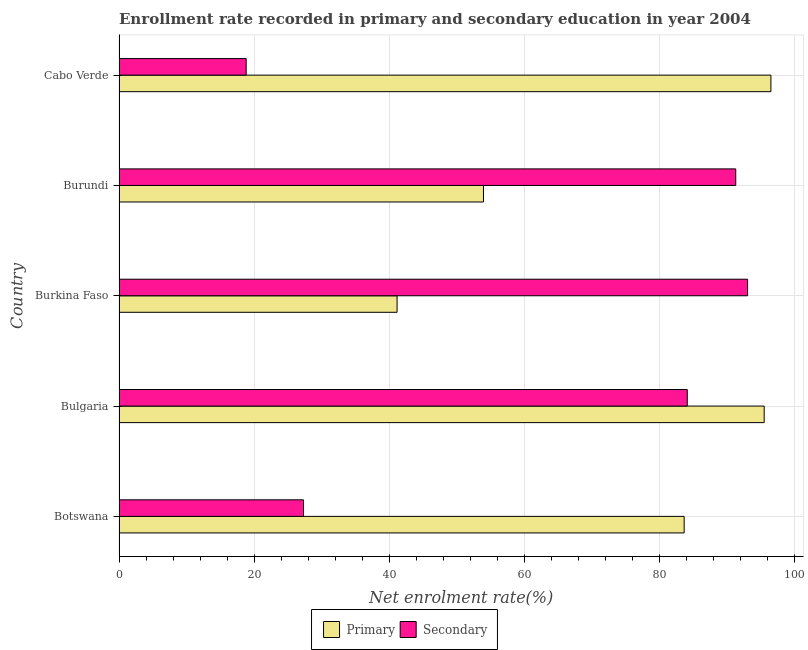How many different coloured bars are there?
Your answer should be compact. 2. Are the number of bars on each tick of the Y-axis equal?
Ensure brevity in your answer.  Yes. What is the label of the 4th group of bars from the top?
Your response must be concise. Bulgaria. What is the enrollment rate in primary education in Burundi?
Give a very brief answer. 53.93. Across all countries, what is the maximum enrollment rate in primary education?
Offer a very short reply. 96.46. Across all countries, what is the minimum enrollment rate in primary education?
Provide a short and direct response. 41.14. In which country was the enrollment rate in secondary education maximum?
Provide a short and direct response. Burkina Faso. In which country was the enrollment rate in primary education minimum?
Make the answer very short. Burkina Faso. What is the total enrollment rate in primary education in the graph?
Give a very brief answer. 370.61. What is the difference between the enrollment rate in primary education in Bulgaria and that in Cabo Verde?
Give a very brief answer. -0.99. What is the difference between the enrollment rate in secondary education in Burundi and the enrollment rate in primary education in Cabo Verde?
Ensure brevity in your answer.  -5.2. What is the average enrollment rate in primary education per country?
Ensure brevity in your answer.  74.12. What is the difference between the enrollment rate in primary education and enrollment rate in secondary education in Burundi?
Your answer should be compact. -37.33. What is the ratio of the enrollment rate in secondary education in Bulgaria to that in Cabo Verde?
Provide a short and direct response. 4.47. What is the difference between the highest and the second highest enrollment rate in secondary education?
Keep it short and to the point. 1.75. What is the difference between the highest and the lowest enrollment rate in primary education?
Make the answer very short. 55.32. In how many countries, is the enrollment rate in secondary education greater than the average enrollment rate in secondary education taken over all countries?
Your answer should be very brief. 3. Is the sum of the enrollment rate in secondary education in Botswana and Burundi greater than the maximum enrollment rate in primary education across all countries?
Your response must be concise. Yes. What does the 2nd bar from the top in Burkina Faso represents?
Provide a short and direct response. Primary. What does the 1st bar from the bottom in Cabo Verde represents?
Ensure brevity in your answer.  Primary. Are all the bars in the graph horizontal?
Give a very brief answer. Yes. How many countries are there in the graph?
Ensure brevity in your answer.  5. What is the difference between two consecutive major ticks on the X-axis?
Provide a short and direct response. 20. Are the values on the major ticks of X-axis written in scientific E-notation?
Ensure brevity in your answer.  No. Does the graph contain grids?
Offer a terse response. Yes. How are the legend labels stacked?
Make the answer very short. Horizontal. What is the title of the graph?
Provide a succinct answer. Enrollment rate recorded in primary and secondary education in year 2004. Does "% of GNI" appear as one of the legend labels in the graph?
Keep it short and to the point. No. What is the label or title of the X-axis?
Your response must be concise. Net enrolment rate(%). What is the label or title of the Y-axis?
Provide a short and direct response. Country. What is the Net enrolment rate(%) of Primary in Botswana?
Keep it short and to the point. 83.62. What is the Net enrolment rate(%) of Secondary in Botswana?
Offer a very short reply. 27.29. What is the Net enrolment rate(%) of Primary in Bulgaria?
Provide a succinct answer. 95.46. What is the Net enrolment rate(%) of Secondary in Bulgaria?
Give a very brief answer. 84.08. What is the Net enrolment rate(%) in Primary in Burkina Faso?
Provide a short and direct response. 41.14. What is the Net enrolment rate(%) of Secondary in Burkina Faso?
Your answer should be compact. 93.01. What is the Net enrolment rate(%) in Primary in Burundi?
Give a very brief answer. 53.93. What is the Net enrolment rate(%) in Secondary in Burundi?
Offer a terse response. 91.26. What is the Net enrolment rate(%) of Primary in Cabo Verde?
Keep it short and to the point. 96.46. What is the Net enrolment rate(%) of Secondary in Cabo Verde?
Your answer should be compact. 18.81. Across all countries, what is the maximum Net enrolment rate(%) in Primary?
Ensure brevity in your answer.  96.46. Across all countries, what is the maximum Net enrolment rate(%) of Secondary?
Provide a short and direct response. 93.01. Across all countries, what is the minimum Net enrolment rate(%) in Primary?
Provide a short and direct response. 41.14. Across all countries, what is the minimum Net enrolment rate(%) of Secondary?
Your response must be concise. 18.81. What is the total Net enrolment rate(%) in Primary in the graph?
Offer a terse response. 370.61. What is the total Net enrolment rate(%) of Secondary in the graph?
Keep it short and to the point. 314.45. What is the difference between the Net enrolment rate(%) of Primary in Botswana and that in Bulgaria?
Give a very brief answer. -11.84. What is the difference between the Net enrolment rate(%) in Secondary in Botswana and that in Bulgaria?
Make the answer very short. -56.79. What is the difference between the Net enrolment rate(%) of Primary in Botswana and that in Burkina Faso?
Your answer should be compact. 42.48. What is the difference between the Net enrolment rate(%) of Secondary in Botswana and that in Burkina Faso?
Offer a very short reply. -65.71. What is the difference between the Net enrolment rate(%) of Primary in Botswana and that in Burundi?
Offer a very short reply. 29.7. What is the difference between the Net enrolment rate(%) in Secondary in Botswana and that in Burundi?
Ensure brevity in your answer.  -63.96. What is the difference between the Net enrolment rate(%) in Primary in Botswana and that in Cabo Verde?
Offer a very short reply. -12.84. What is the difference between the Net enrolment rate(%) of Secondary in Botswana and that in Cabo Verde?
Provide a succinct answer. 8.49. What is the difference between the Net enrolment rate(%) of Primary in Bulgaria and that in Burkina Faso?
Give a very brief answer. 54.32. What is the difference between the Net enrolment rate(%) in Secondary in Bulgaria and that in Burkina Faso?
Your response must be concise. -8.93. What is the difference between the Net enrolment rate(%) of Primary in Bulgaria and that in Burundi?
Give a very brief answer. 41.54. What is the difference between the Net enrolment rate(%) of Secondary in Bulgaria and that in Burundi?
Provide a succinct answer. -7.18. What is the difference between the Net enrolment rate(%) in Primary in Bulgaria and that in Cabo Verde?
Give a very brief answer. -0.99. What is the difference between the Net enrolment rate(%) of Secondary in Bulgaria and that in Cabo Verde?
Your answer should be very brief. 65.27. What is the difference between the Net enrolment rate(%) in Primary in Burkina Faso and that in Burundi?
Your response must be concise. -12.78. What is the difference between the Net enrolment rate(%) in Secondary in Burkina Faso and that in Burundi?
Provide a short and direct response. 1.75. What is the difference between the Net enrolment rate(%) of Primary in Burkina Faso and that in Cabo Verde?
Offer a terse response. -55.32. What is the difference between the Net enrolment rate(%) of Secondary in Burkina Faso and that in Cabo Verde?
Your answer should be very brief. 74.2. What is the difference between the Net enrolment rate(%) in Primary in Burundi and that in Cabo Verde?
Give a very brief answer. -42.53. What is the difference between the Net enrolment rate(%) in Secondary in Burundi and that in Cabo Verde?
Your answer should be compact. 72.45. What is the difference between the Net enrolment rate(%) in Primary in Botswana and the Net enrolment rate(%) in Secondary in Bulgaria?
Make the answer very short. -0.46. What is the difference between the Net enrolment rate(%) in Primary in Botswana and the Net enrolment rate(%) in Secondary in Burkina Faso?
Offer a very short reply. -9.39. What is the difference between the Net enrolment rate(%) of Primary in Botswana and the Net enrolment rate(%) of Secondary in Burundi?
Your answer should be compact. -7.63. What is the difference between the Net enrolment rate(%) of Primary in Botswana and the Net enrolment rate(%) of Secondary in Cabo Verde?
Give a very brief answer. 64.81. What is the difference between the Net enrolment rate(%) of Primary in Bulgaria and the Net enrolment rate(%) of Secondary in Burkina Faso?
Provide a succinct answer. 2.46. What is the difference between the Net enrolment rate(%) in Primary in Bulgaria and the Net enrolment rate(%) in Secondary in Burundi?
Keep it short and to the point. 4.21. What is the difference between the Net enrolment rate(%) in Primary in Bulgaria and the Net enrolment rate(%) in Secondary in Cabo Verde?
Offer a very short reply. 76.65. What is the difference between the Net enrolment rate(%) in Primary in Burkina Faso and the Net enrolment rate(%) in Secondary in Burundi?
Your answer should be very brief. -50.12. What is the difference between the Net enrolment rate(%) in Primary in Burkina Faso and the Net enrolment rate(%) in Secondary in Cabo Verde?
Provide a succinct answer. 22.33. What is the difference between the Net enrolment rate(%) of Primary in Burundi and the Net enrolment rate(%) of Secondary in Cabo Verde?
Your response must be concise. 35.12. What is the average Net enrolment rate(%) of Primary per country?
Offer a very short reply. 74.12. What is the average Net enrolment rate(%) in Secondary per country?
Provide a short and direct response. 62.89. What is the difference between the Net enrolment rate(%) of Primary and Net enrolment rate(%) of Secondary in Botswana?
Give a very brief answer. 56.33. What is the difference between the Net enrolment rate(%) in Primary and Net enrolment rate(%) in Secondary in Bulgaria?
Offer a terse response. 11.38. What is the difference between the Net enrolment rate(%) in Primary and Net enrolment rate(%) in Secondary in Burkina Faso?
Make the answer very short. -51.87. What is the difference between the Net enrolment rate(%) in Primary and Net enrolment rate(%) in Secondary in Burundi?
Provide a succinct answer. -37.33. What is the difference between the Net enrolment rate(%) of Primary and Net enrolment rate(%) of Secondary in Cabo Verde?
Make the answer very short. 77.65. What is the ratio of the Net enrolment rate(%) of Primary in Botswana to that in Bulgaria?
Give a very brief answer. 0.88. What is the ratio of the Net enrolment rate(%) of Secondary in Botswana to that in Bulgaria?
Make the answer very short. 0.32. What is the ratio of the Net enrolment rate(%) in Primary in Botswana to that in Burkina Faso?
Make the answer very short. 2.03. What is the ratio of the Net enrolment rate(%) in Secondary in Botswana to that in Burkina Faso?
Make the answer very short. 0.29. What is the ratio of the Net enrolment rate(%) of Primary in Botswana to that in Burundi?
Ensure brevity in your answer.  1.55. What is the ratio of the Net enrolment rate(%) in Secondary in Botswana to that in Burundi?
Provide a short and direct response. 0.3. What is the ratio of the Net enrolment rate(%) in Primary in Botswana to that in Cabo Verde?
Make the answer very short. 0.87. What is the ratio of the Net enrolment rate(%) in Secondary in Botswana to that in Cabo Verde?
Your response must be concise. 1.45. What is the ratio of the Net enrolment rate(%) of Primary in Bulgaria to that in Burkina Faso?
Offer a very short reply. 2.32. What is the ratio of the Net enrolment rate(%) in Secondary in Bulgaria to that in Burkina Faso?
Your answer should be very brief. 0.9. What is the ratio of the Net enrolment rate(%) in Primary in Bulgaria to that in Burundi?
Offer a terse response. 1.77. What is the ratio of the Net enrolment rate(%) in Secondary in Bulgaria to that in Burundi?
Offer a terse response. 0.92. What is the ratio of the Net enrolment rate(%) in Secondary in Bulgaria to that in Cabo Verde?
Keep it short and to the point. 4.47. What is the ratio of the Net enrolment rate(%) of Primary in Burkina Faso to that in Burundi?
Keep it short and to the point. 0.76. What is the ratio of the Net enrolment rate(%) of Secondary in Burkina Faso to that in Burundi?
Keep it short and to the point. 1.02. What is the ratio of the Net enrolment rate(%) in Primary in Burkina Faso to that in Cabo Verde?
Ensure brevity in your answer.  0.43. What is the ratio of the Net enrolment rate(%) of Secondary in Burkina Faso to that in Cabo Verde?
Your answer should be compact. 4.94. What is the ratio of the Net enrolment rate(%) of Primary in Burundi to that in Cabo Verde?
Provide a short and direct response. 0.56. What is the ratio of the Net enrolment rate(%) of Secondary in Burundi to that in Cabo Verde?
Offer a terse response. 4.85. What is the difference between the highest and the second highest Net enrolment rate(%) in Primary?
Your response must be concise. 0.99. What is the difference between the highest and the second highest Net enrolment rate(%) in Secondary?
Give a very brief answer. 1.75. What is the difference between the highest and the lowest Net enrolment rate(%) of Primary?
Ensure brevity in your answer.  55.32. What is the difference between the highest and the lowest Net enrolment rate(%) of Secondary?
Provide a succinct answer. 74.2. 